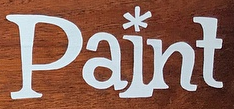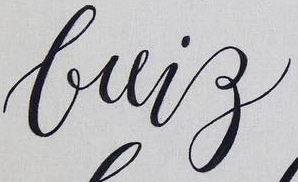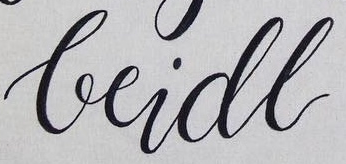What text appears in these images from left to right, separated by a semicolon? Paint; brig; beidl 